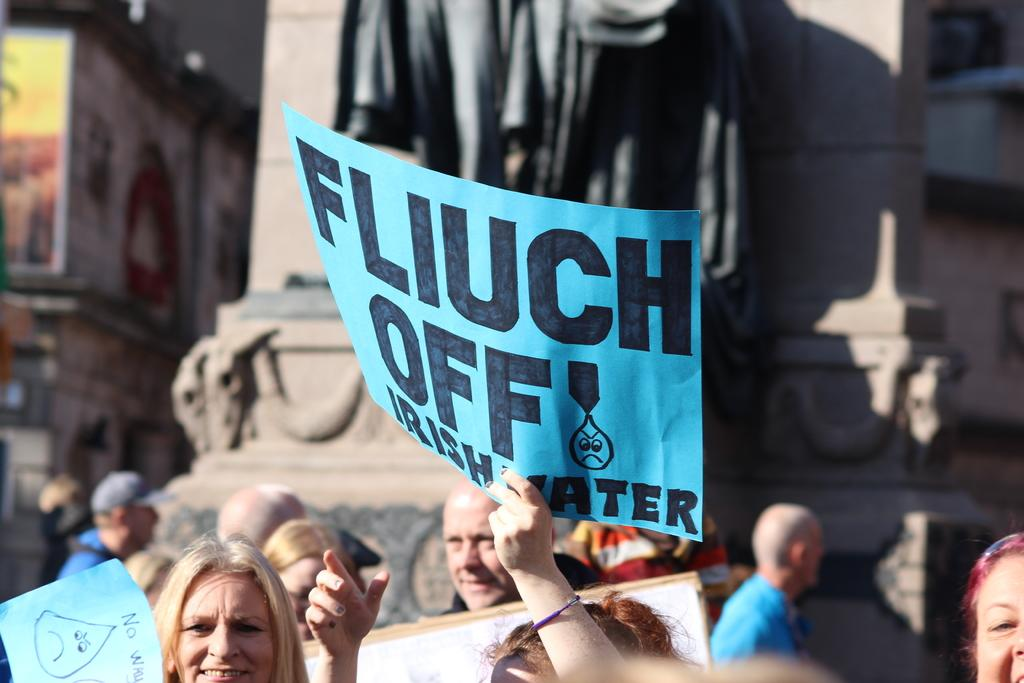What are the people in the foreground of the image doing? The people in the foreground of the image are holding placards. What can be seen in the background of the image? There is a sculpture in the background of the image. How would you describe the background of the image? The background is blurred. What is the weather like in the image? It is sunny in the image. What type of stamp can be seen on the sculpture in the image? There is no stamp visible on the sculpture in the image. How many sticks are being used by the people holding placards in the image? The people holding placards in the image are not using any sticks. 